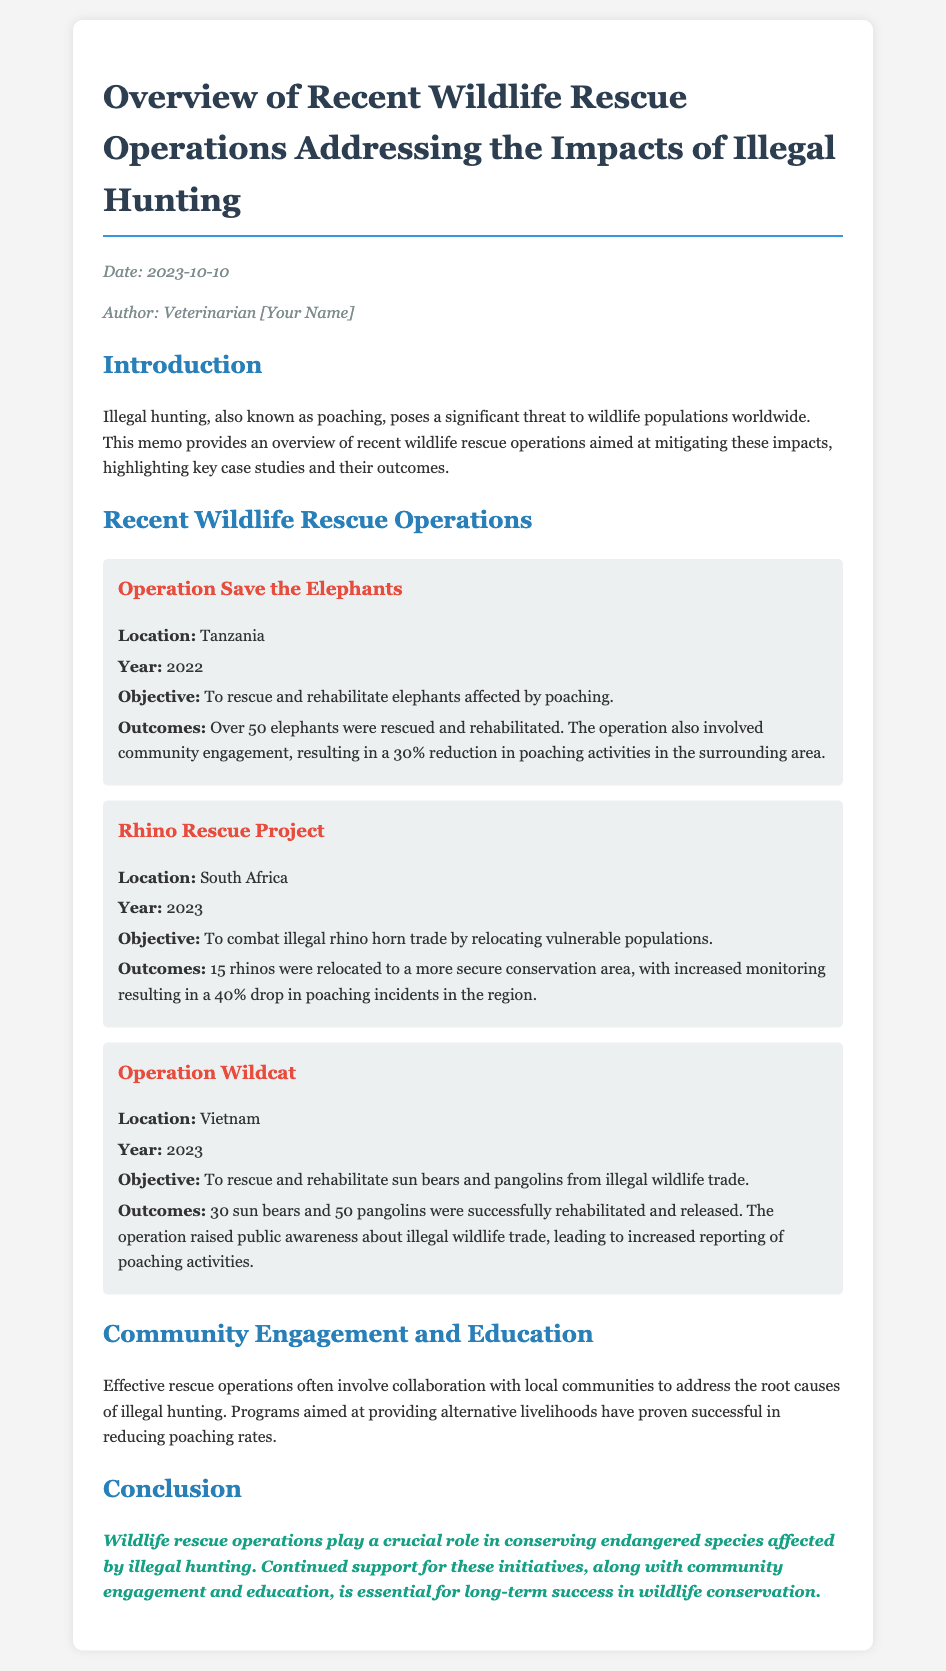What was the date of the memo? The date of the memo is stated in the metadata section at the beginning, which is 2023-10-10.
Answer: 2023-10-10 What was the objective of Operation Save the Elephants? The objective is detailed in the section about the operation and is to rescue and rehabilitate elephants affected by poaching.
Answer: To rescue and rehabilitate elephants affected by poaching How many elephants were rescued in Operation Save the Elephants? The number of elephants rescued is mentioned in the outcomes section for this operation, which states over 50 elephants were rescued.
Answer: Over 50 Which country hosted the Rhino Rescue Project? The location is specified in the operation section, indicating it took place in South Africa.
Answer: South Africa What was the outcome of relocating 15 rhinos? The outcomes for this operation discuss the results, stating that there was a 40% drop in poaching incidents in the region.
Answer: 40% drop What significant impact did Operation Wildcat have on public awareness? The memo mentions the raised public awareness about illegal wildlife trade as an outcome of this operation.
Answer: Increased reporting of poaching activities What role does community engagement play in wildlife rescue operations? The document discusses community engagement in the context of effective rescue operations, particularly addressing the root causes of illegal hunting.
Answer: Collaboration with local communities What is emphasized as essential for long-term success in wildlife conservation? The conclusion highlights the importance of continued support for initiatives along with community engagement and education as essential for success.
Answer: Community engagement and education 